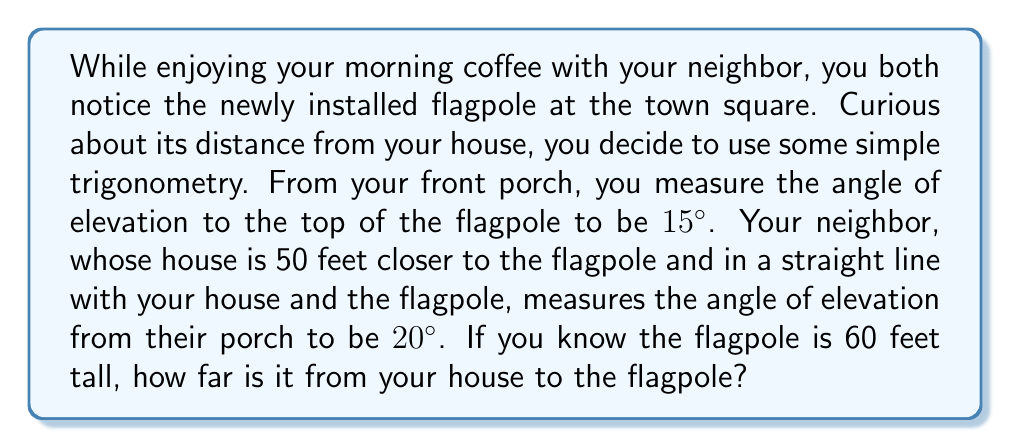Solve this math problem. Let's approach this step-by-step:

1) Let's define variables:
   $x$ = distance from your house to the flagpole
   $h$ = height of the flagpole = 60 feet

2) We can set up two tangent equations:
   From your house: $\tan(15°) = \frac{h}{x}$
   From your neighbor's house: $\tan(20°) = \frac{h}{x-50}$

3) Let's solve the first equation for $h$:
   $h = x \tan(15°)$

4) Substitute this into the second equation:
   $\tan(20°) = \frac{x \tan(15°)}{x-50}$

5) Cross multiply:
   $\tan(20°)(x-50) = x \tan(15°)$

6) Expand:
   $x \tan(20°) - 50 \tan(20°) = x \tan(15°)$

7) Rearrange:
   $x \tan(20°) - x \tan(15°) = 50 \tan(20°)$
   $x(\tan(20°) - \tan(15°)) = 50 \tan(20°)$

8) Solve for $x$:
   $x = \frac{50 \tan(20°)}{\tan(20°) - \tan(15°)}$

9) Calculate:
   $x = \frac{50 \cdot 0.3640}{0.3640 - 0.2679} \approx 189.7$ feet

Therefore, the flagpole is approximately 189.7 feet from your house.
Answer: $$x \approx 189.7 \text{ feet}$$ 